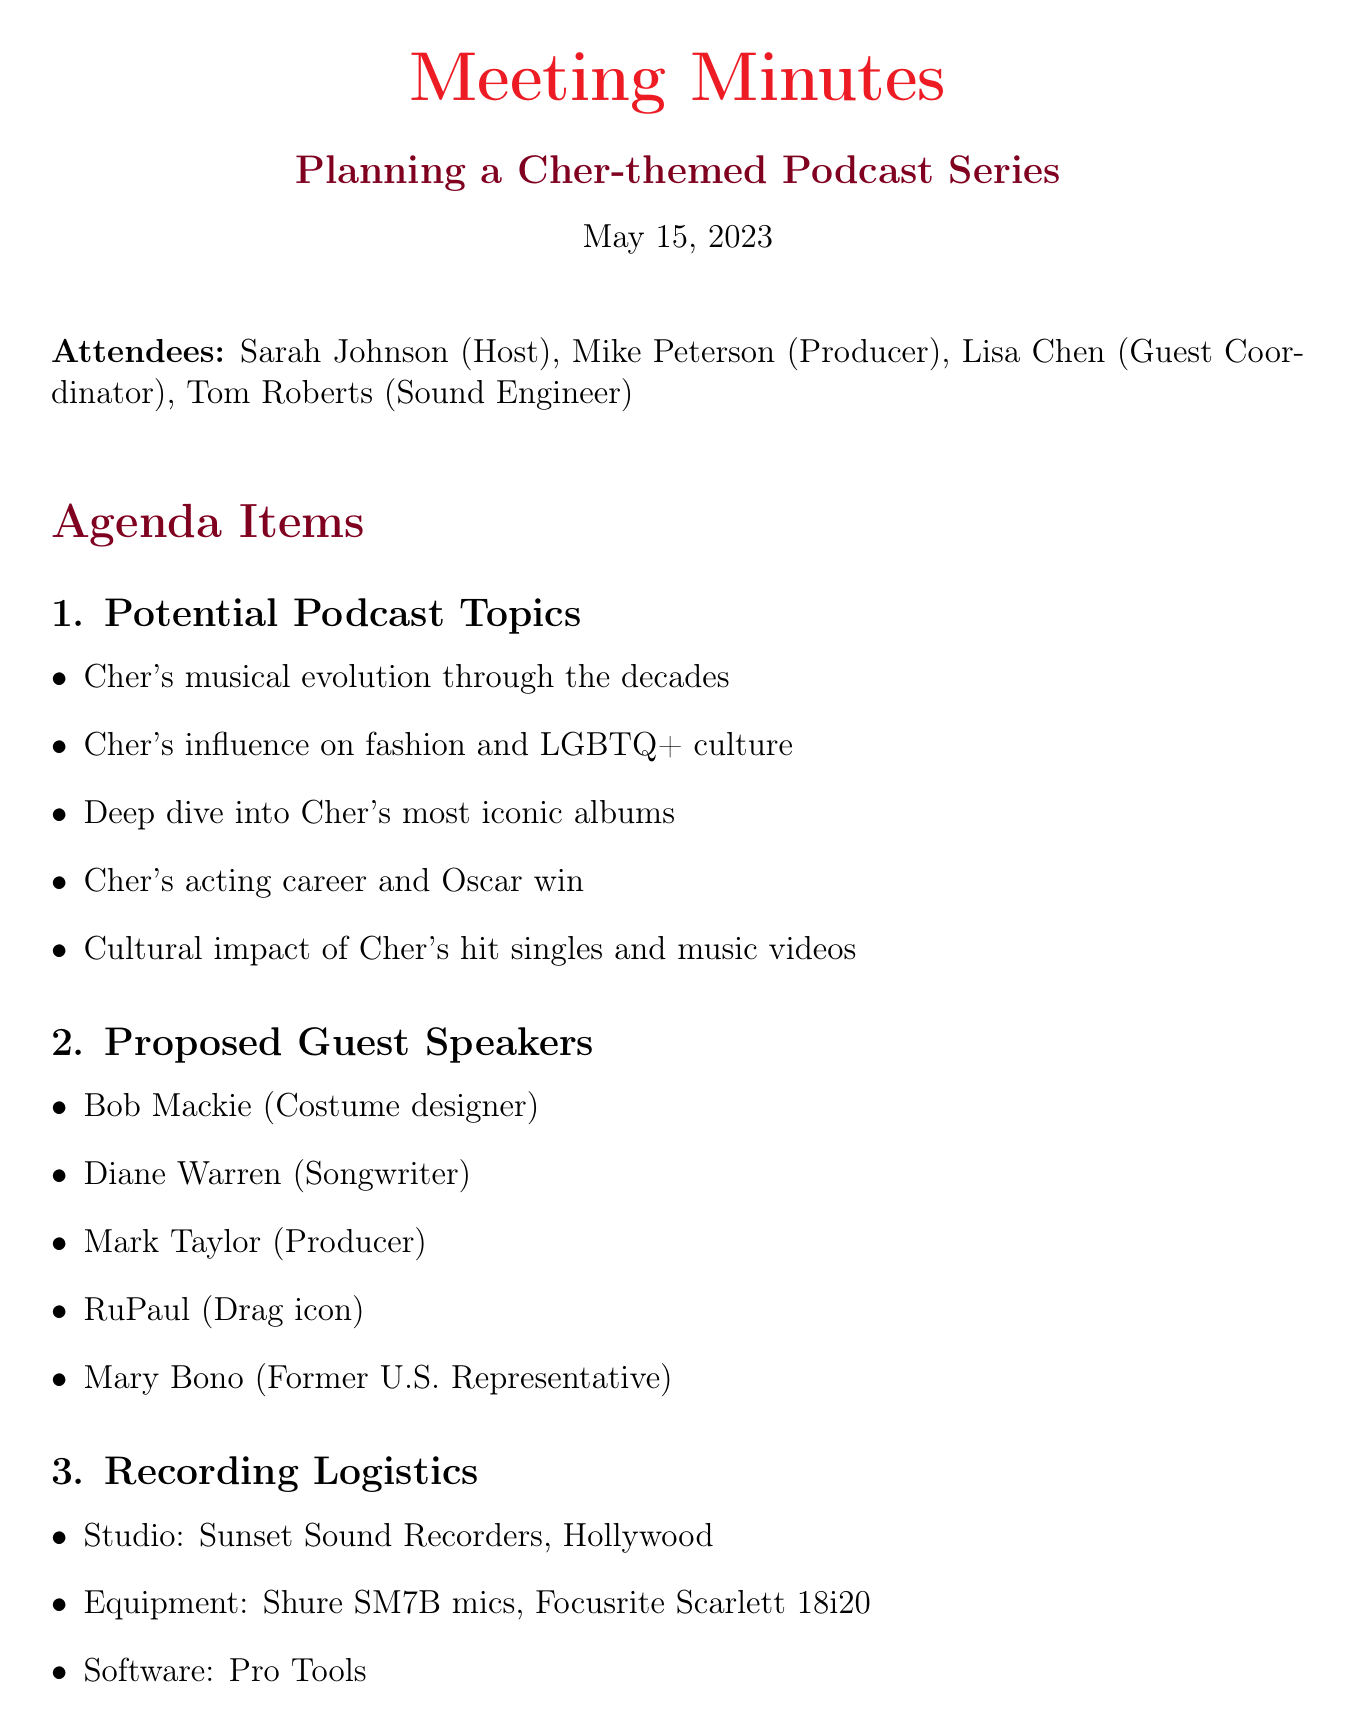what is the date of the meeting? The date of the meeting is clearly specified in the document as May 15, 2023.
Answer: May 15, 2023 who is the host of the podcast series? The host of the podcast series is mentioned as Sarah Johnson in the attendees list.
Answer: Sarah Johnson what is one proposed guest speaker? The document lists several proposed guest speakers; one example is Bob Mackie.
Answer: Bob Mackie how long is the episode expected to be? The expected episode length is specified to be between 45 to 60 minutes.
Answer: 45-60 minutes what is one topic discussed in the meeting? The document outlines several potential topics; one example is Cher's influence on fashion and LGBTQ+ culture.
Answer: Cher's influence on fashion and LGBTQ+ culture how often will new episodes be released? The release schedule is mentioned as bi-weekly on Fridays.
Answer: Bi-weekly on Fridays who is responsible for testing the equipment? The action item lists that Tom is responsible for testing the equipment at Sunset Sound Recorders.
Answer: Tom what type of equipment will be used for recording? The document specifies that Shure SM7B microphones and a Focusrite Scarlett 18i20 interface will be used.
Answer: Shure SM7B microphones, Focusrite Scarlett 18i20 interface 